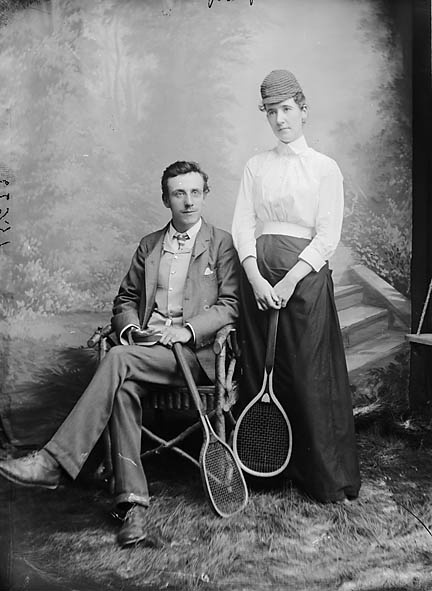Describe the objects in this image and their specific colors. I can see people in gray, black, gainsboro, and darkgray tones, people in gray, darkgray, black, and lightgray tones, chair in gray, black, darkgray, and lightgray tones, tennis racket in gray, black, darkgray, and lightgray tones, and tennis racket in gray, black, darkgray, and lightgray tones in this image. 